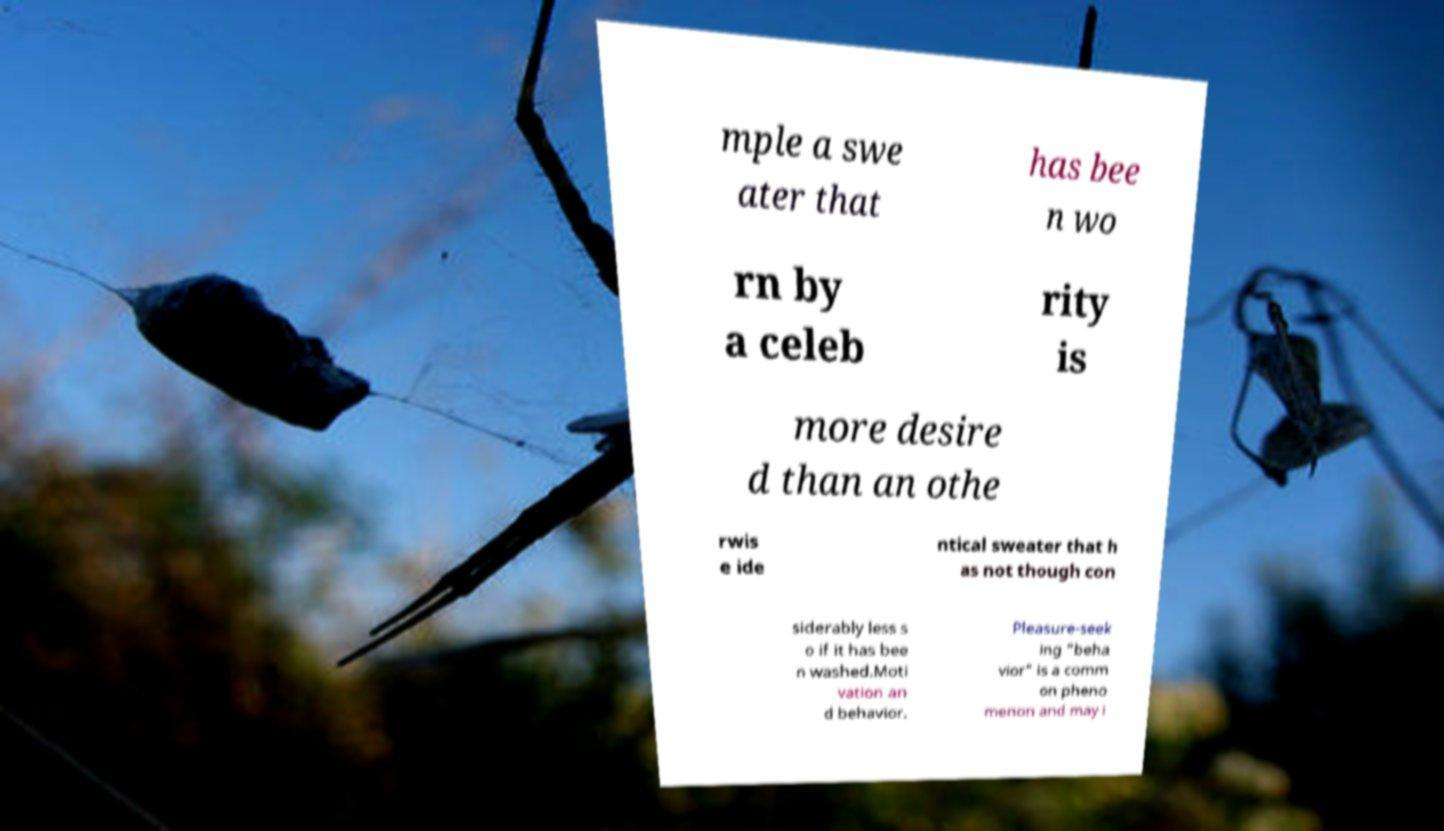Can you read and provide the text displayed in the image?This photo seems to have some interesting text. Can you extract and type it out for me? mple a swe ater that has bee n wo rn by a celeb rity is more desire d than an othe rwis e ide ntical sweater that h as not though con siderably less s o if it has bee n washed.Moti vation an d behavior. Pleasure-seek ing "beha vior" is a comm on pheno menon and may i 